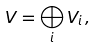<formula> <loc_0><loc_0><loc_500><loc_500>V = \bigoplus _ { i } V _ { i } \, ,</formula> 